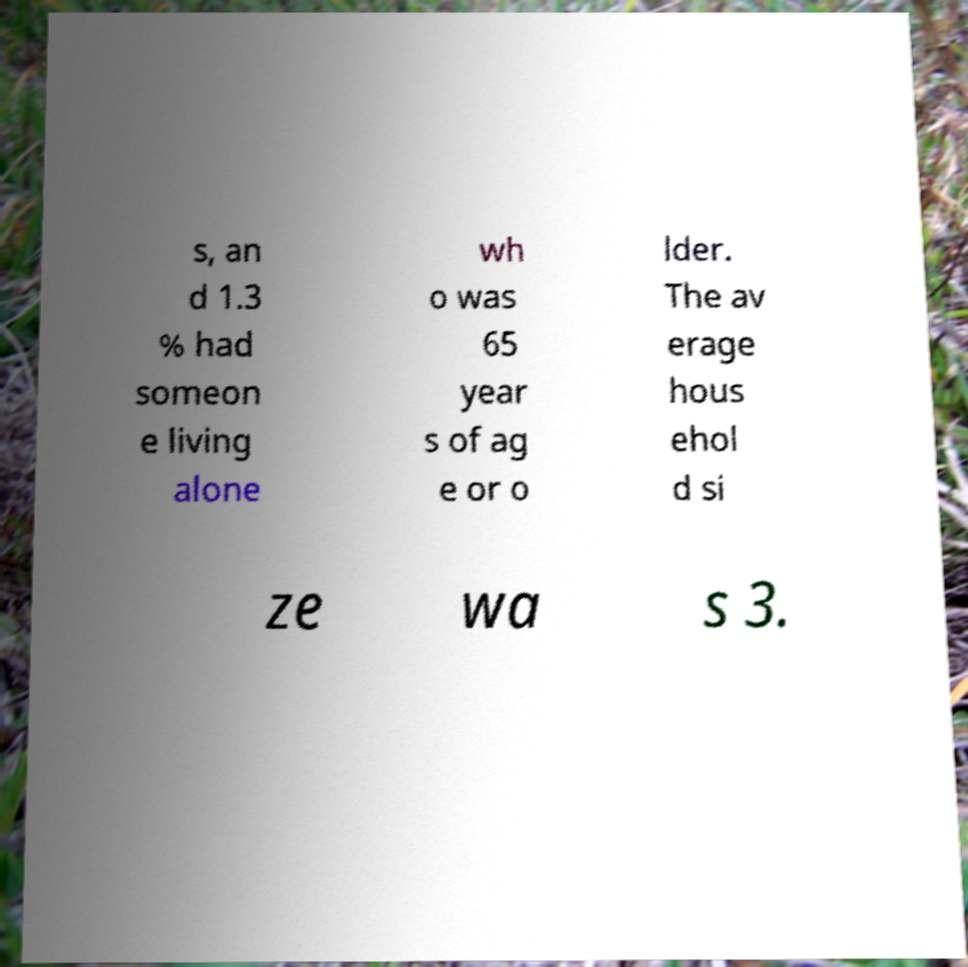Could you extract and type out the text from this image? s, an d 1.3 % had someon e living alone wh o was 65 year s of ag e or o lder. The av erage hous ehol d si ze wa s 3. 